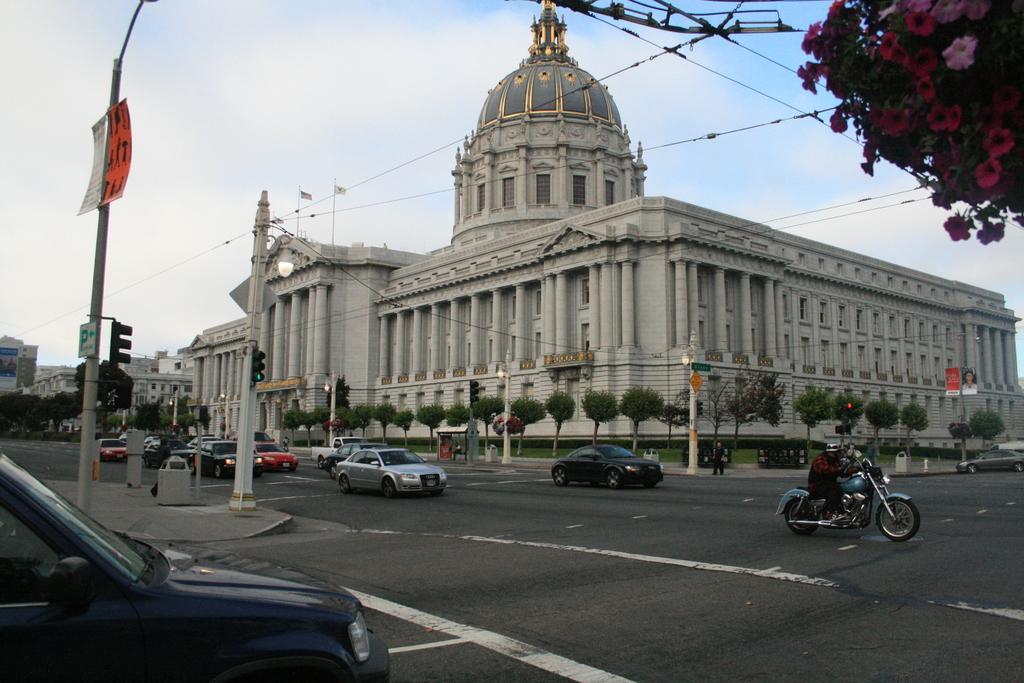Describe this image in one or two sentences. In this image I can see few buildings, windows, trees, traffic signals, poles, boards, flags, light poles and few vehicles on the road. The sky is in blue and white color. 